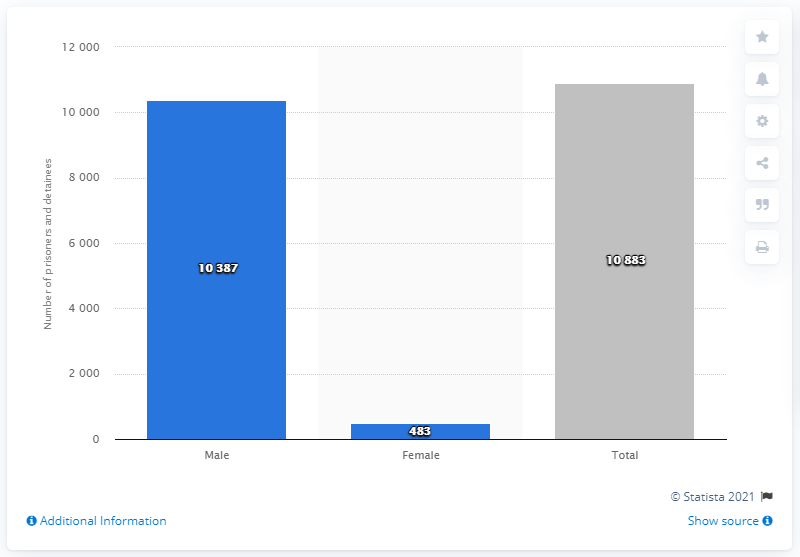Draw attention to some important aspects in this diagram. In 2019, a total of 483 female detainees were registered in Belgian prisons. 